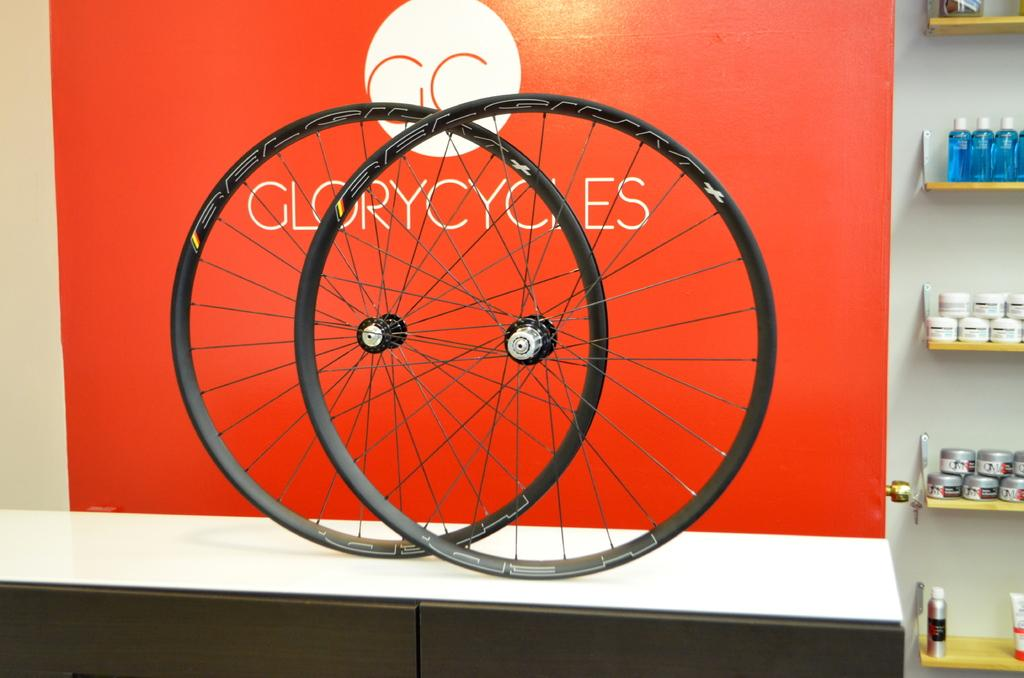What objects are on the table in the image? There are two wheels on the table. What is located to the right of the table? There are bottles and objects in a rack to the right of the table. What can be seen on the wall in the background? There is a board on the wall in the background. What direction is the mother facing in the image? There is no mother present in the image. What type of teeth can be seen in the image? There are no teeth visible in the image. 